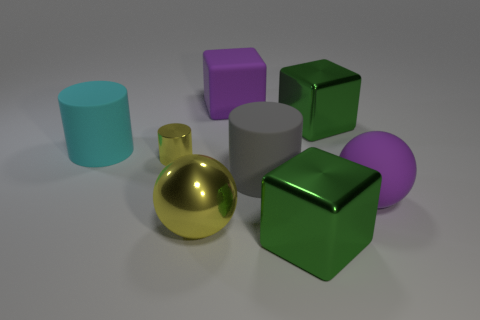Can you describe the different materials of the objects shown in the image? Certainly! The objects display a variety of materials, with the green cube and purple cube appearing matte and the gold sphere having a reflective metallic finish. The cyan cylinder looks like smooth plastic, and the silver sphere and grey cylinder might be made of a dull metal or rubber. 